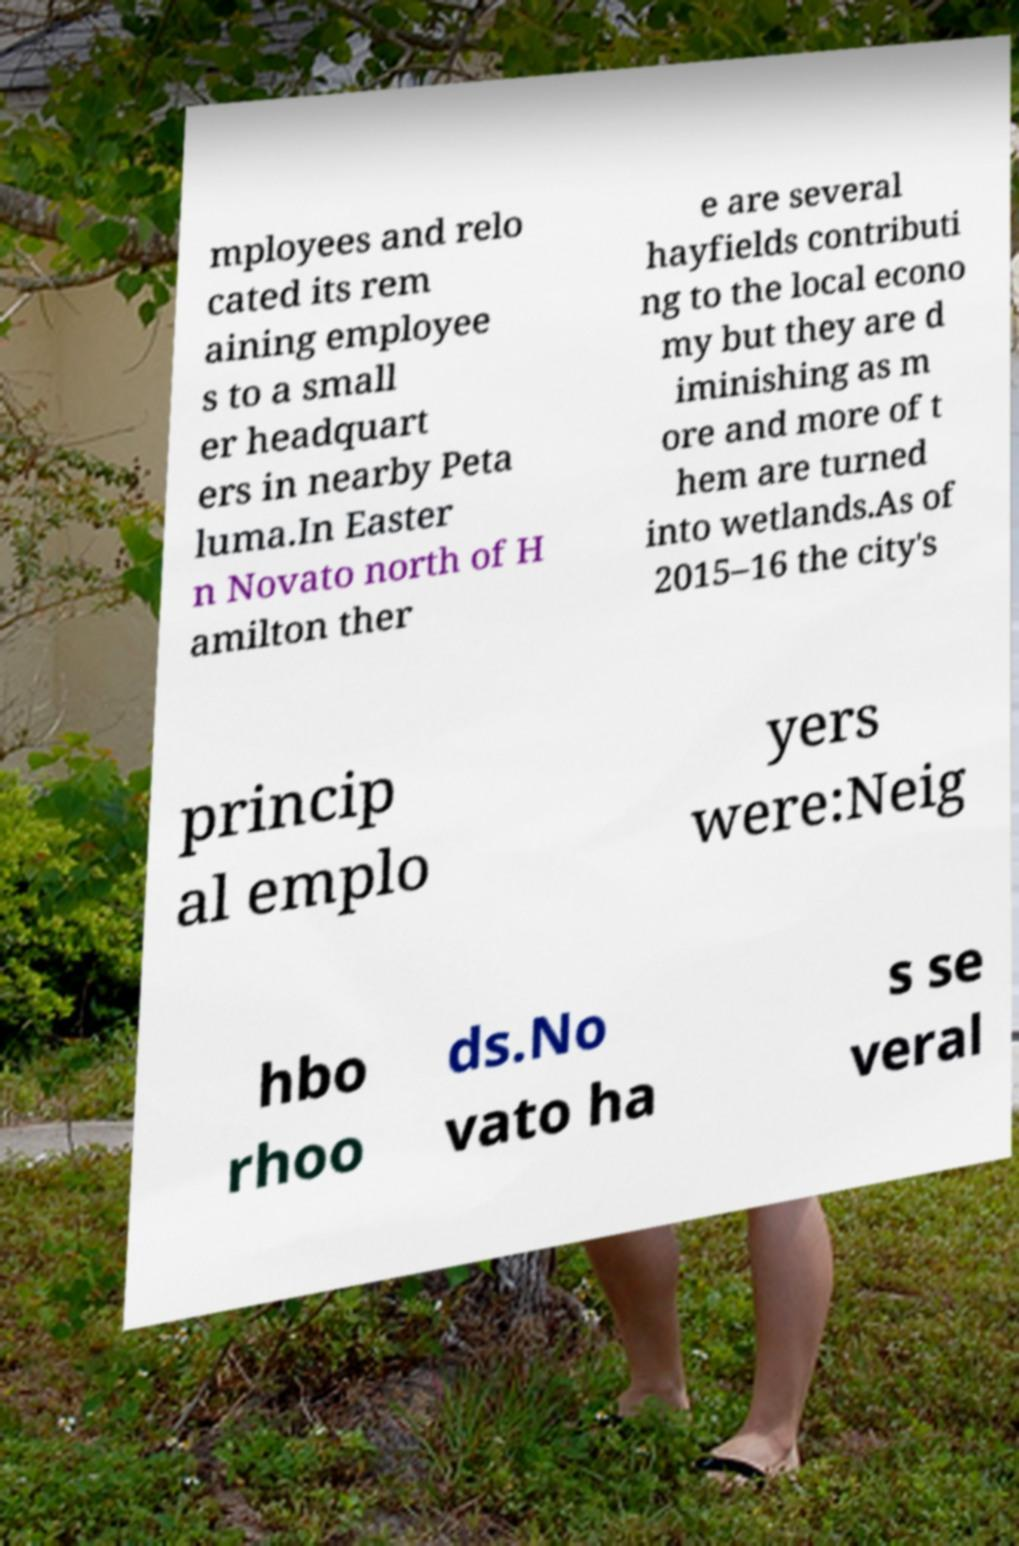Please identify and transcribe the text found in this image. mployees and relo cated its rem aining employee s to a small er headquart ers in nearby Peta luma.In Easter n Novato north of H amilton ther e are several hayfields contributi ng to the local econo my but they are d iminishing as m ore and more of t hem are turned into wetlands.As of 2015–16 the city's princip al emplo yers were:Neig hbo rhoo ds.No vato ha s se veral 